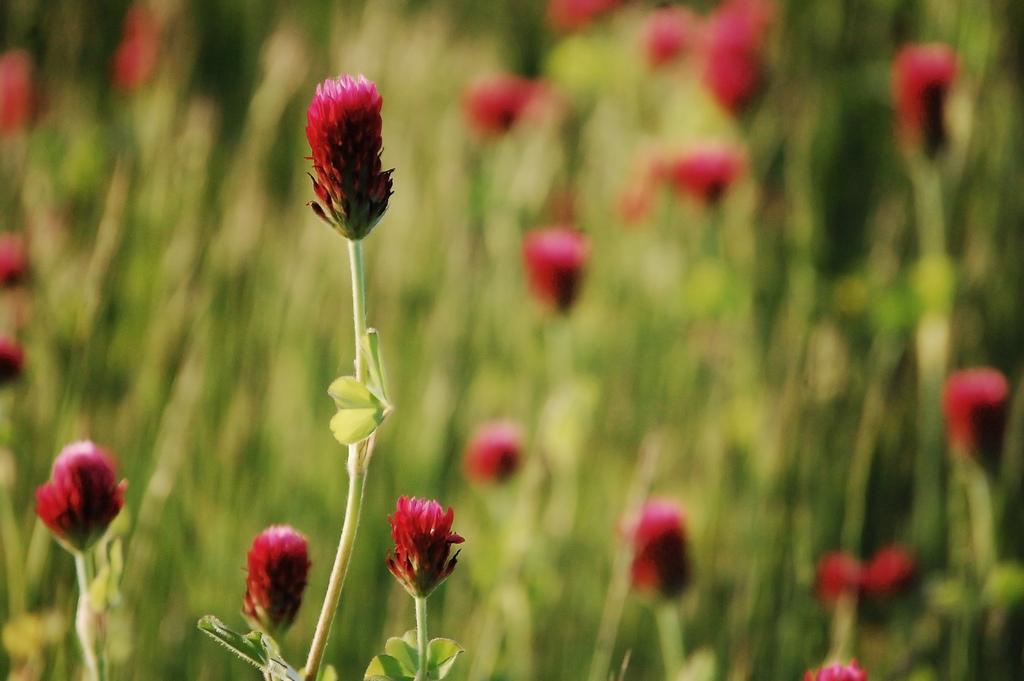Can you describe this image briefly? In this picture we can see flowers, stems and leaves. In the background of the image it is blurry. 